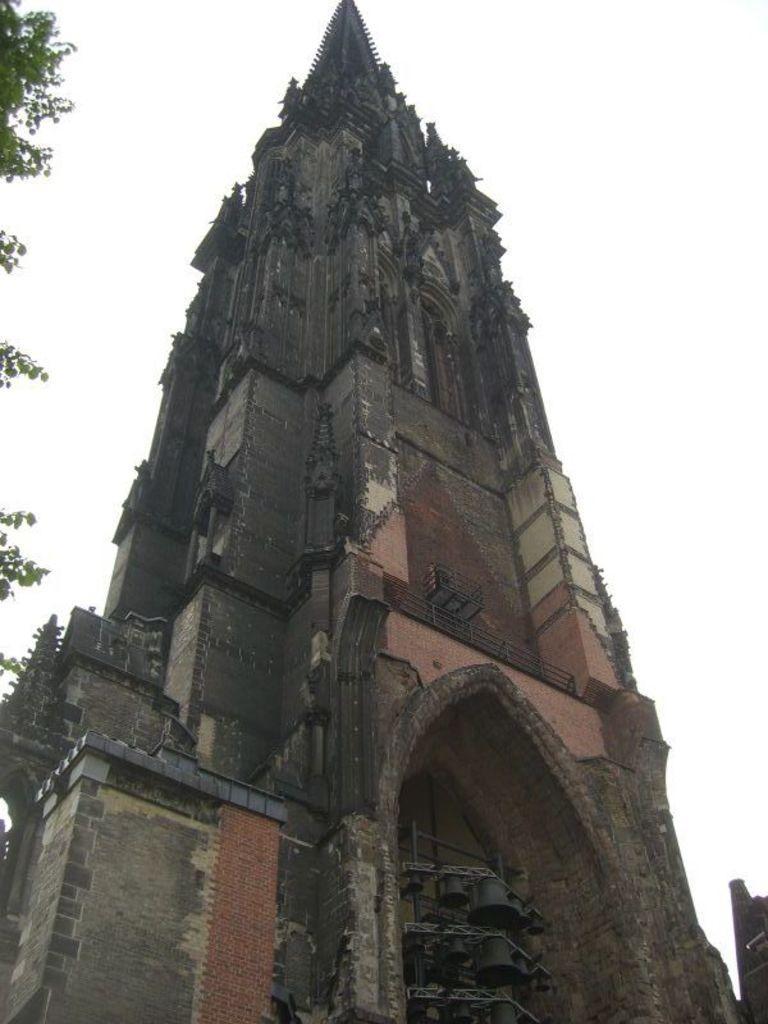Could you give a brief overview of what you see in this image? In this image we can see a monument and a tree. 